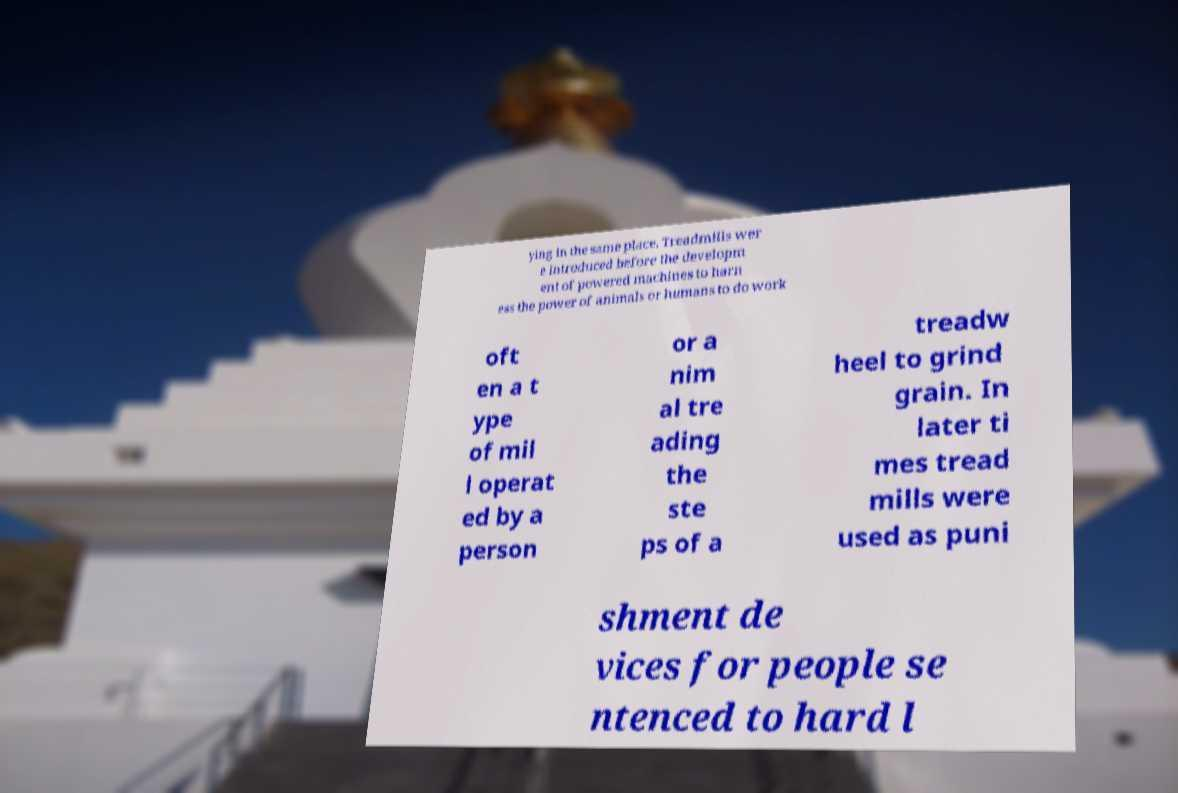Can you accurately transcribe the text from the provided image for me? ying in the same place. Treadmills wer e introduced before the developm ent of powered machines to harn ess the power of animals or humans to do work oft en a t ype of mil l operat ed by a person or a nim al tre ading the ste ps of a treadw heel to grind grain. In later ti mes tread mills were used as puni shment de vices for people se ntenced to hard l 